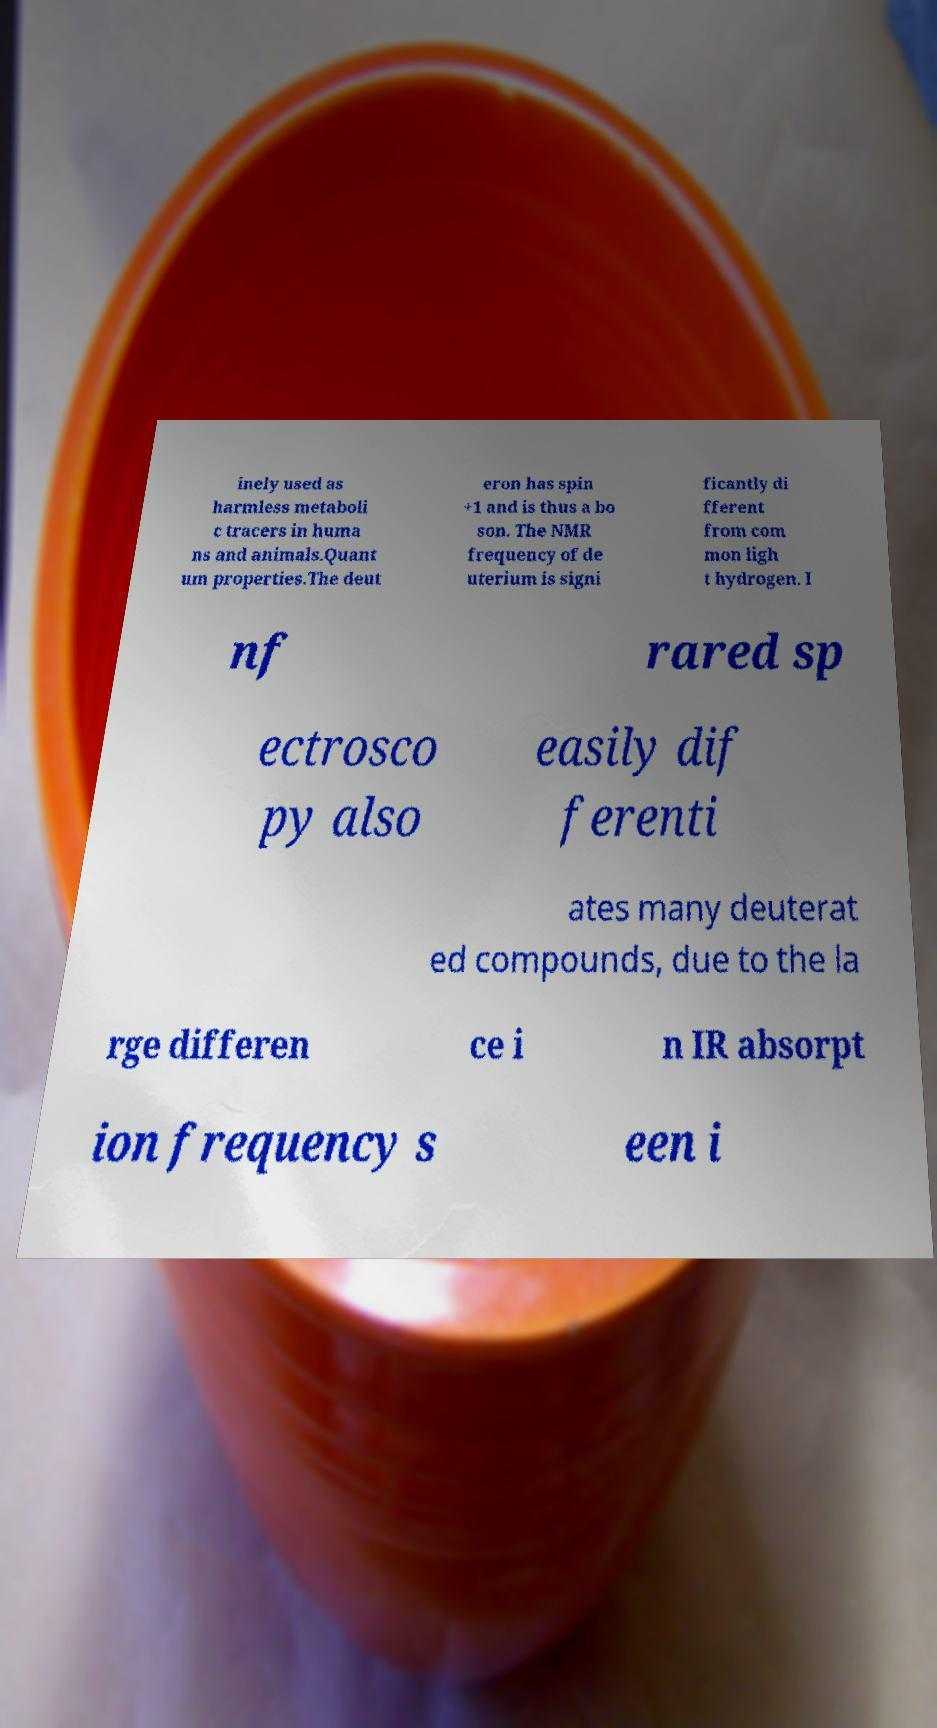I need the written content from this picture converted into text. Can you do that? inely used as harmless metaboli c tracers in huma ns and animals.Quant um properties.The deut eron has spin +1 and is thus a bo son. The NMR frequency of de uterium is signi ficantly di fferent from com mon ligh t hydrogen. I nf rared sp ectrosco py also easily dif ferenti ates many deuterat ed compounds, due to the la rge differen ce i n IR absorpt ion frequency s een i 